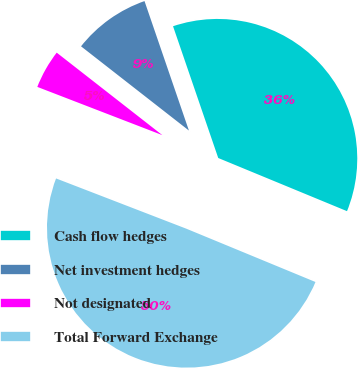<chart> <loc_0><loc_0><loc_500><loc_500><pie_chart><fcel>Cash flow hedges<fcel>Net investment hedges<fcel>Not designated<fcel>Total Forward Exchange<nl><fcel>36.49%<fcel>9.19%<fcel>4.69%<fcel>49.63%<nl></chart> 